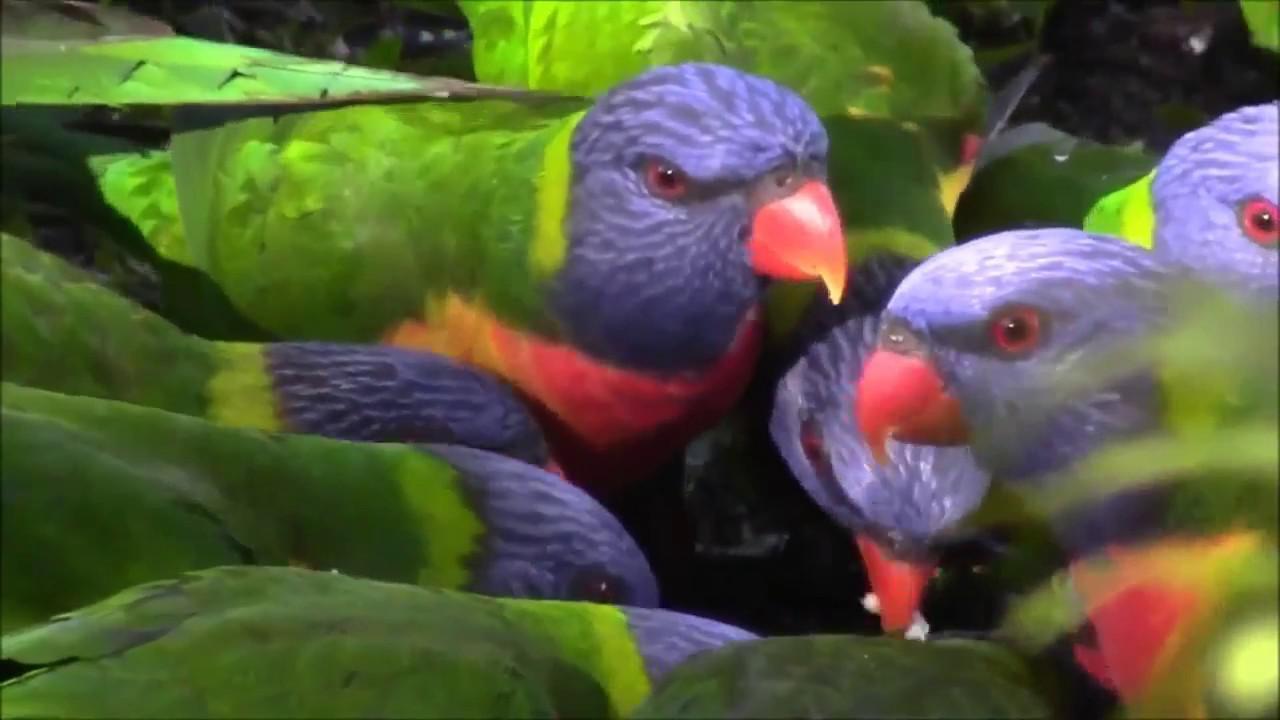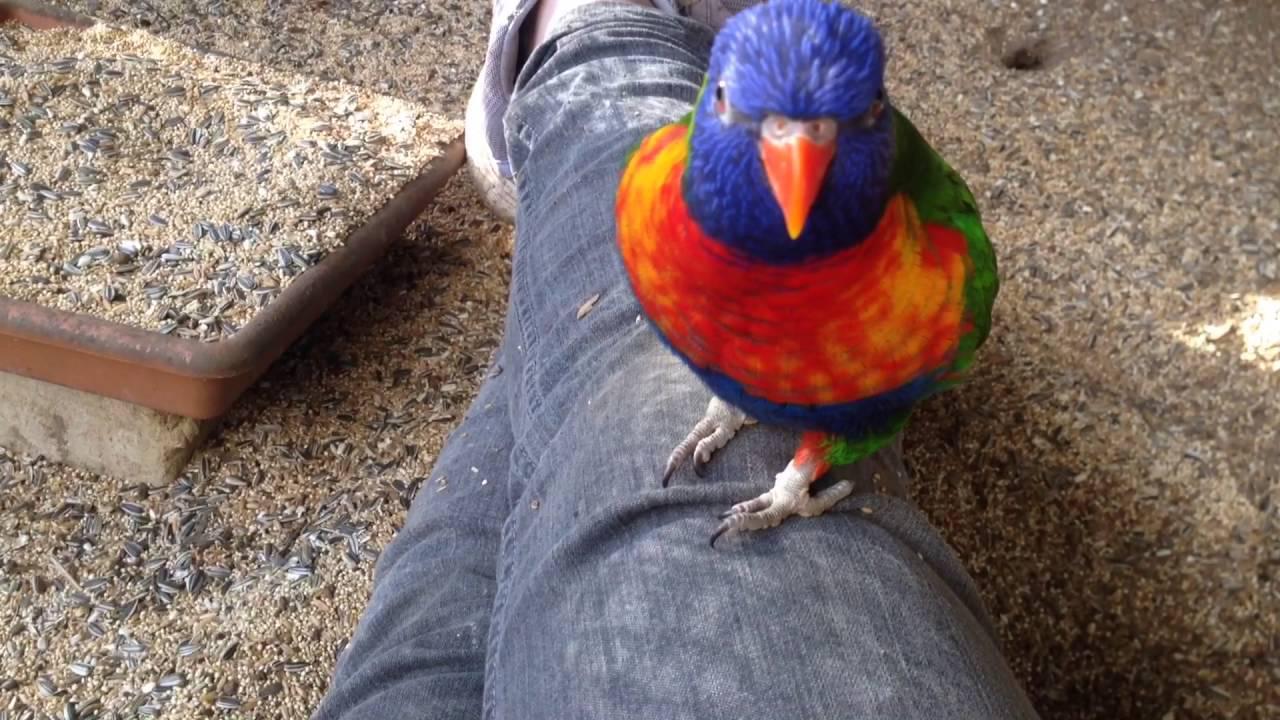The first image is the image on the left, the second image is the image on the right. For the images displayed, is the sentence "One bird is upside down." factually correct? Answer yes or no. No. The first image is the image on the left, the second image is the image on the right. Analyze the images presented: Is the assertion "Part of a human is pictured with a single bird in one of the images." valid? Answer yes or no. Yes. 